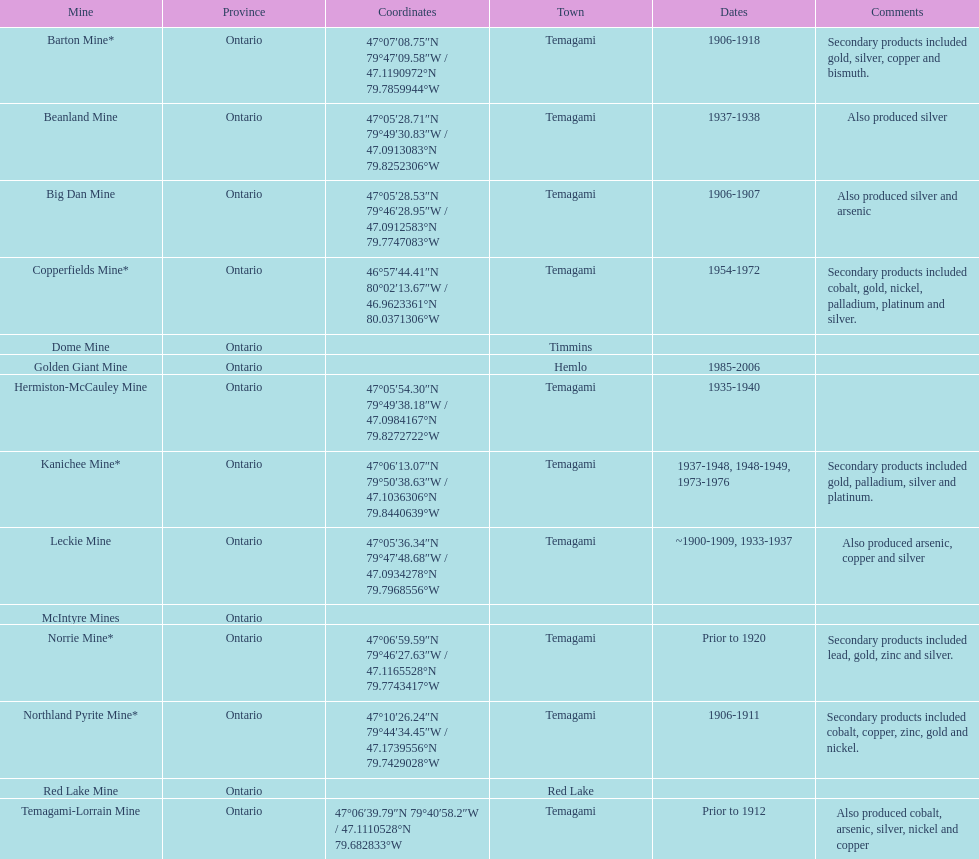What mine is in the town of timmins? Dome Mine. 